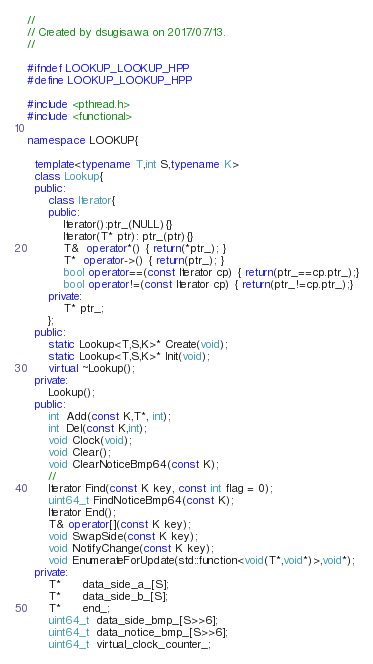Convert code to text. <code><loc_0><loc_0><loc_500><loc_500><_C++_>//
// Created by dsugisawa on 2017/07/13.
//

#ifndef LOOKUP_LOOKUP_HPP
#define LOOKUP_LOOKUP_HPP

#include <pthread.h>
#include <functional>

namespace LOOKUP{

  template<typename T,int S,typename K>
  class Lookup{
  public:
      class Iterator{
      public:
          Iterator():ptr_(NULL){}
          Iterator(T* ptr): ptr_(ptr){}
          T&  operator*() { return(*ptr_); }
          T*  operator->() { return(ptr_); }
          bool operator==(const Iterator cp) { return(ptr_==cp.ptr_);}
          bool operator!=(const Iterator cp) { return(ptr_!=cp.ptr_);}
      private:
          T* ptr_;
      };
  public:
      static Lookup<T,S,K>* Create(void);
      static Lookup<T,S,K>* Init(void);
      virtual ~Lookup();
  private:
      Lookup();
  public:
      int  Add(const K,T*, int);
      int  Del(const K,int);
      void Clock(void);
      void Clear();
      void ClearNoticeBmp64(const K);
      //
      Iterator Find(const K key, const int flag = 0);
      uint64_t FindNoticeBmp64(const K);
      Iterator End();
      T& operator[](const K key);
      void SwapSide(const K key);
      void NotifyChange(const K key);
      void EnumerateForUpdate(std::function<void(T*,void*)>,void*);
  private:
      T*      data_side_a_[S];
      T*      data_side_b_[S];
      T*      end_;
      uint64_t  data_side_bmp_[S>>6];
      uint64_t  data_notice_bmp_[S>>6];
      uint64_t  virtual_clock_counter_;</code> 